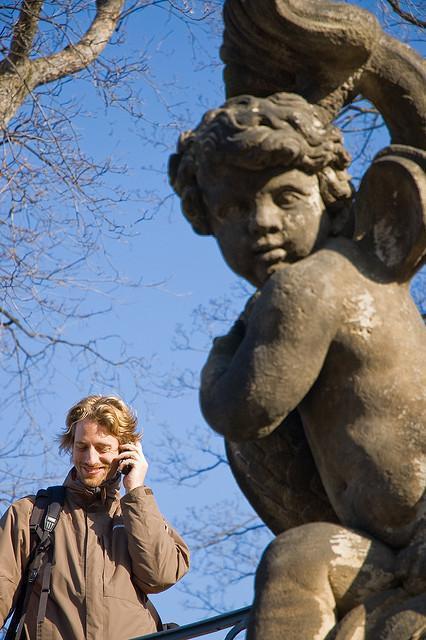What is the grey statue supposed to be?
Indicate the correct response by choosing from the four available options to answer the question.
Options: God, angel, ghost, demon. Angel. 